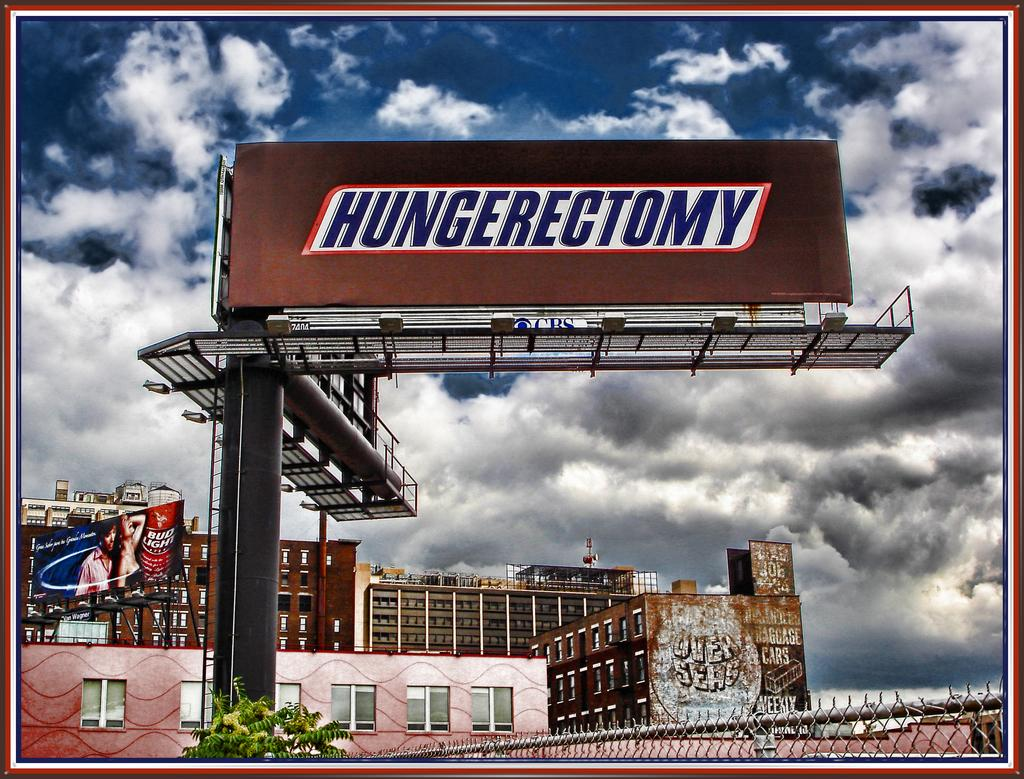<image>
Describe the image concisely. A billboard that says Hungerectomy on it like a Snickers wrapper 